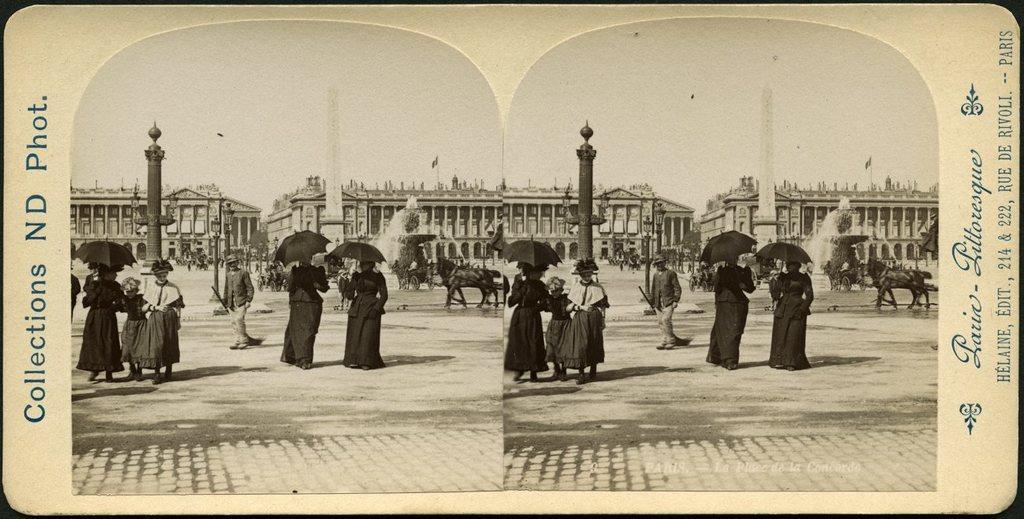Can you describe this image briefly? This picture consists of replica of two images and in the image I can see two persons holding an umbrella in the middle,on the left side I can see three children's and a text and building and pole , in the middle I can see a person and on the right side I can see horses and a building and a flag visible on top of building and the sky visible at the top and the text visible on the right side of the another image in the middle I can see a water fountain and an animal visible in front of the fountain. 